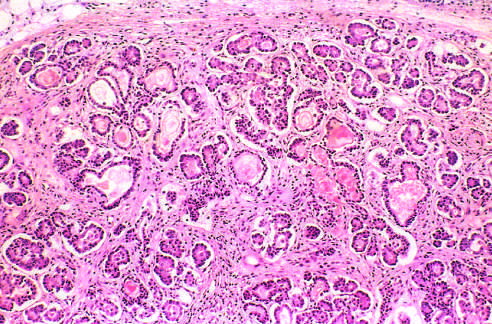re iron deposits shown by a special staining process dilated and plugged with eosinophilic mucin?
Answer the question using a single word or phrase. No 